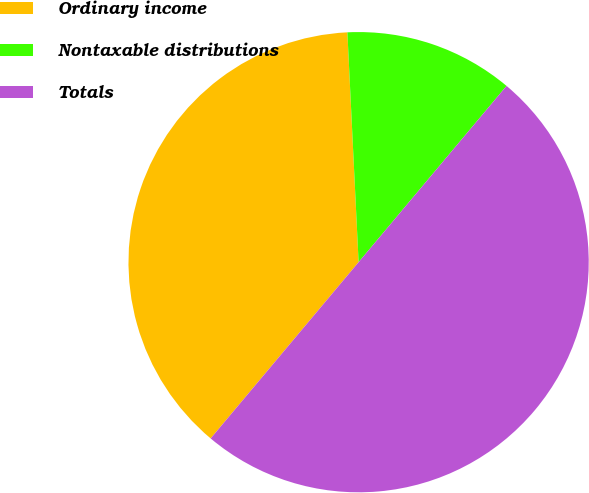Convert chart. <chart><loc_0><loc_0><loc_500><loc_500><pie_chart><fcel>Ordinary income<fcel>Nontaxable distributions<fcel>Totals<nl><fcel>38.11%<fcel>11.89%<fcel>50.0%<nl></chart> 